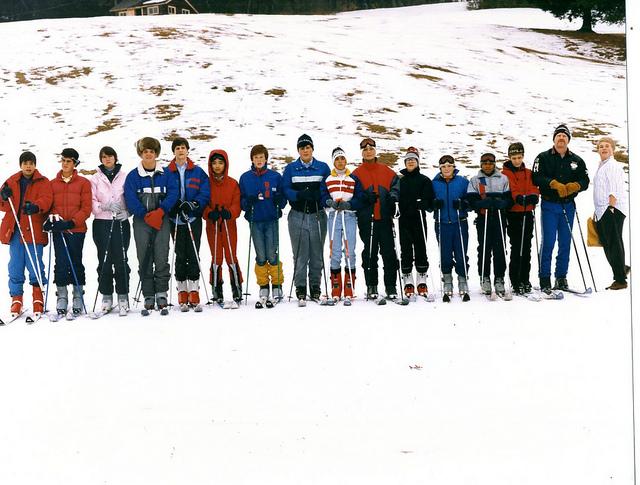What kind of pet is tagging along?
Quick response, please. None. Are all of these people friends?
Write a very short answer. Yes. Are they all on skis?
Quick response, please. Yes. What sport are they going to be doing?
Answer briefly. Skiing. How many people?
Keep it brief. 16. 